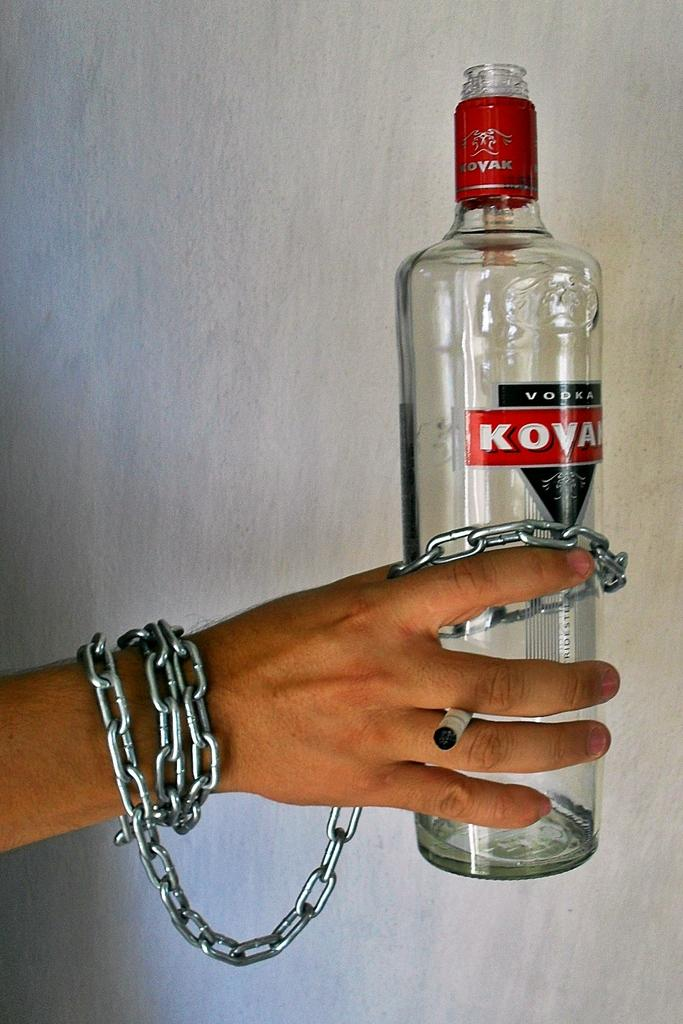<image>
Create a compact narrative representing the image presented. An extended man's hand with a metal chain around this wrist attached to a Kovah bottle of vodka. 